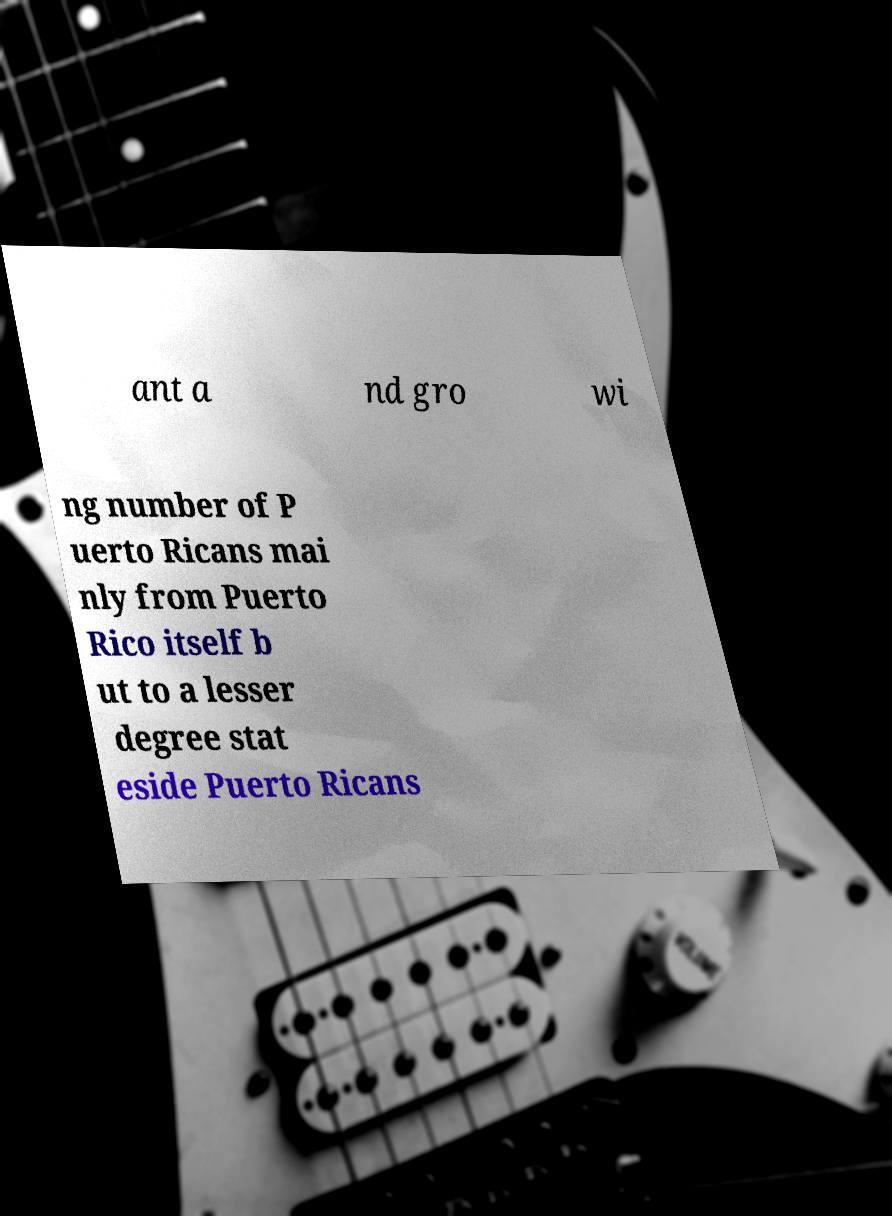Can you read and provide the text displayed in the image?This photo seems to have some interesting text. Can you extract and type it out for me? ant a nd gro wi ng number of P uerto Ricans mai nly from Puerto Rico itself b ut to a lesser degree stat eside Puerto Ricans 